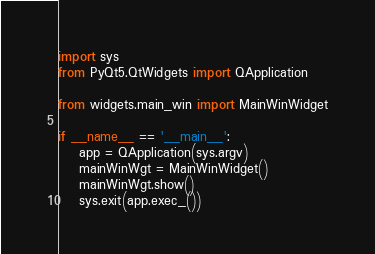Convert code to text. <code><loc_0><loc_0><loc_500><loc_500><_Python_>import sys
from PyQt5.QtWidgets import QApplication

from widgets.main_win import MainWinWidget

if __name__ == '__main__':
    app = QApplication(sys.argv)
    mainWinWgt = MainWinWidget()
    mainWinWgt.show()
    sys.exit(app.exec_())
</code> 